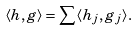<formula> <loc_0><loc_0><loc_500><loc_500>\langle h , g \rangle = \sum \langle h _ { j } , g _ { j } \rangle .</formula> 